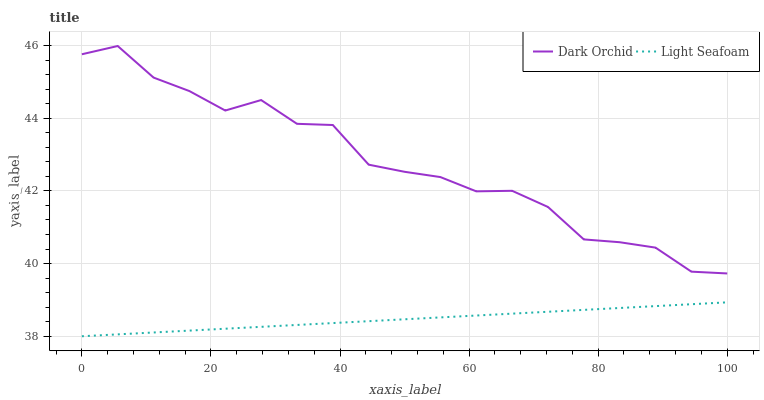Does Light Seafoam have the minimum area under the curve?
Answer yes or no. Yes. Does Dark Orchid have the maximum area under the curve?
Answer yes or no. Yes. Does Dark Orchid have the minimum area under the curve?
Answer yes or no. No. Is Light Seafoam the smoothest?
Answer yes or no. Yes. Is Dark Orchid the roughest?
Answer yes or no. Yes. Is Dark Orchid the smoothest?
Answer yes or no. No. Does Light Seafoam have the lowest value?
Answer yes or no. Yes. Does Dark Orchid have the lowest value?
Answer yes or no. No. Does Dark Orchid have the highest value?
Answer yes or no. Yes. Is Light Seafoam less than Dark Orchid?
Answer yes or no. Yes. Is Dark Orchid greater than Light Seafoam?
Answer yes or no. Yes. Does Light Seafoam intersect Dark Orchid?
Answer yes or no. No. 